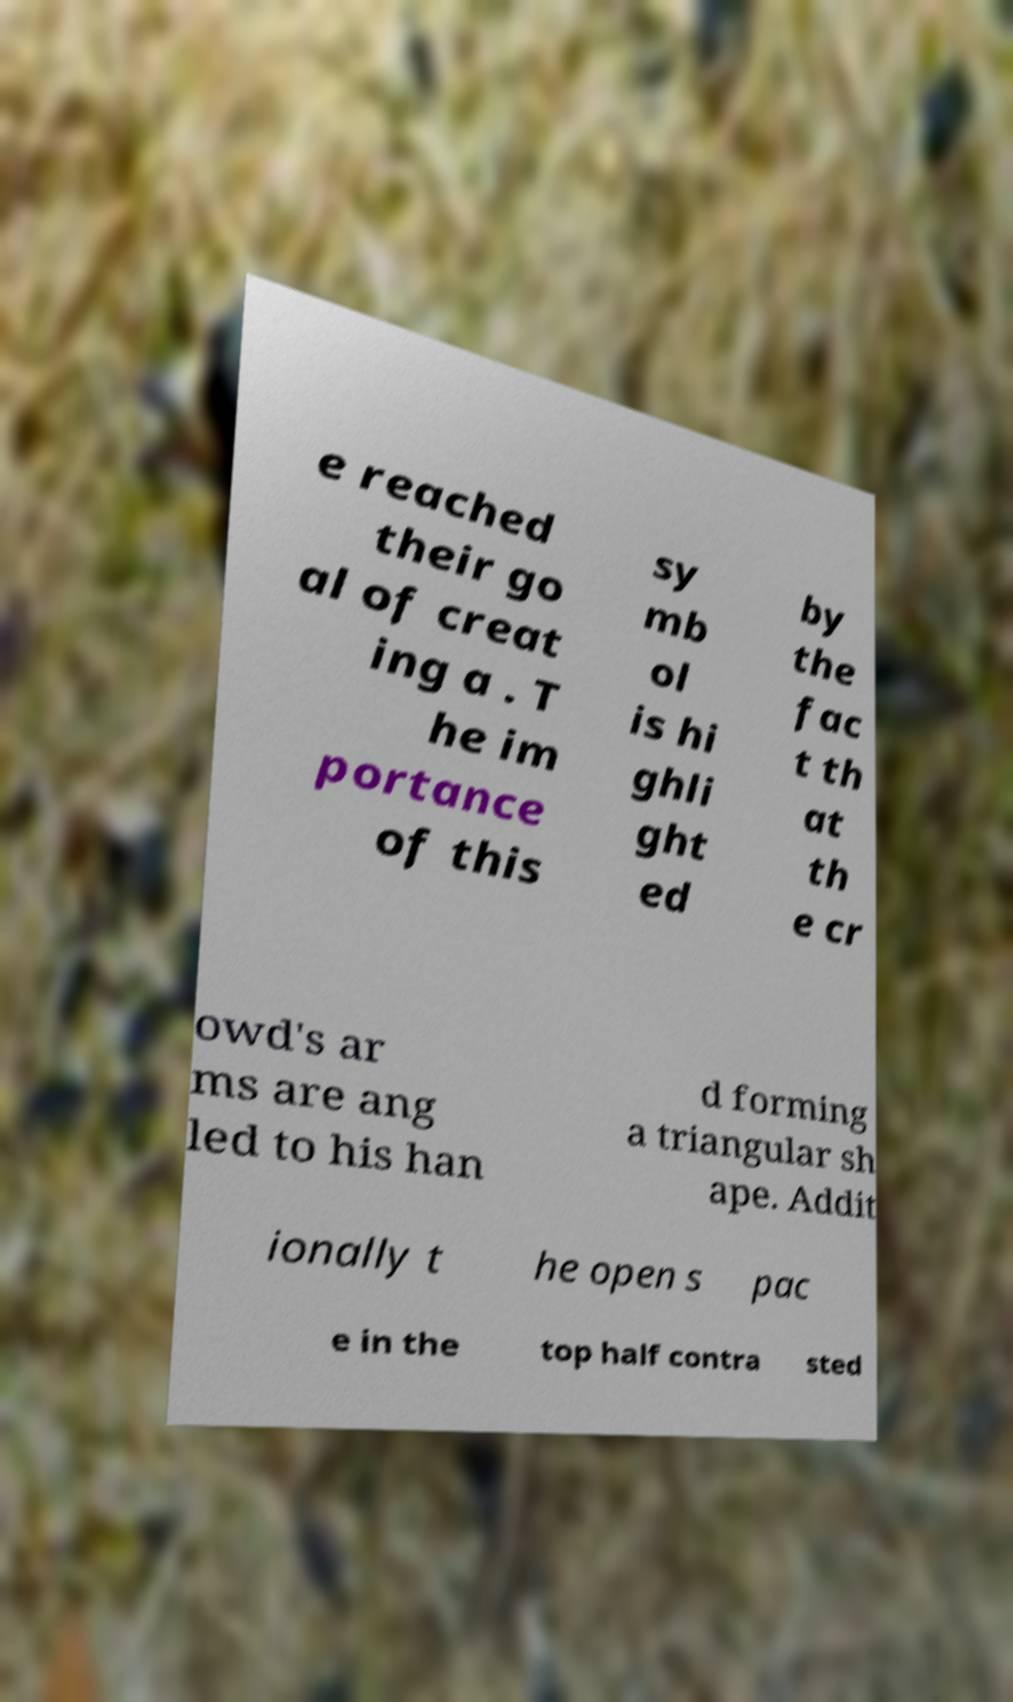For documentation purposes, I need the text within this image transcribed. Could you provide that? e reached their go al of creat ing a . T he im portance of this sy mb ol is hi ghli ght ed by the fac t th at th e cr owd's ar ms are ang led to his han d forming a triangular sh ape. Addit ionally t he open s pac e in the top half contra sted 